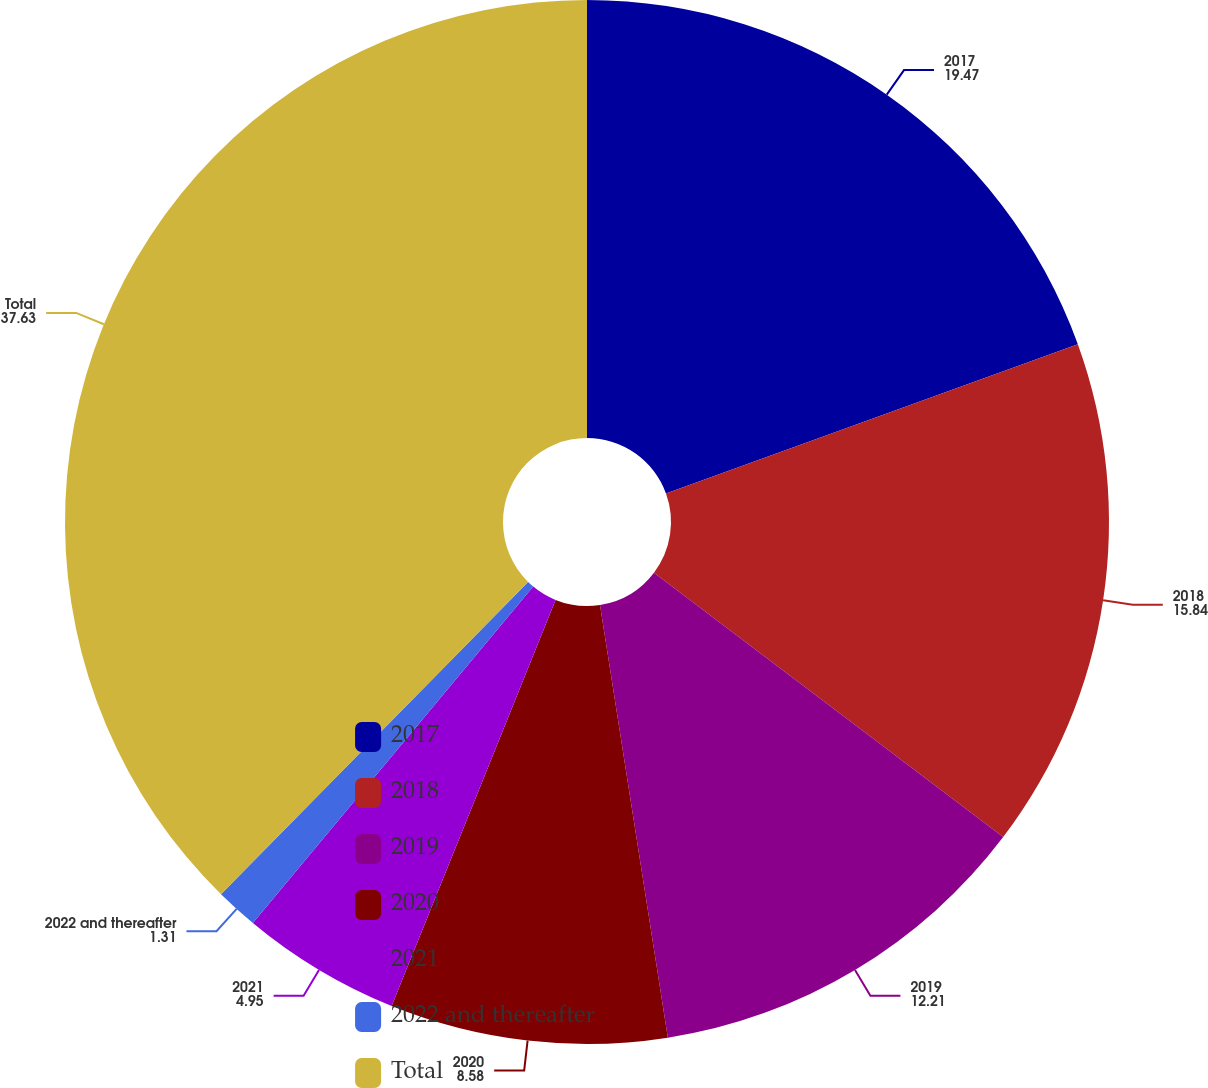Convert chart. <chart><loc_0><loc_0><loc_500><loc_500><pie_chart><fcel>2017<fcel>2018<fcel>2019<fcel>2020<fcel>2021<fcel>2022 and thereafter<fcel>Total<nl><fcel>19.47%<fcel>15.84%<fcel>12.21%<fcel>8.58%<fcel>4.95%<fcel>1.31%<fcel>37.63%<nl></chart> 